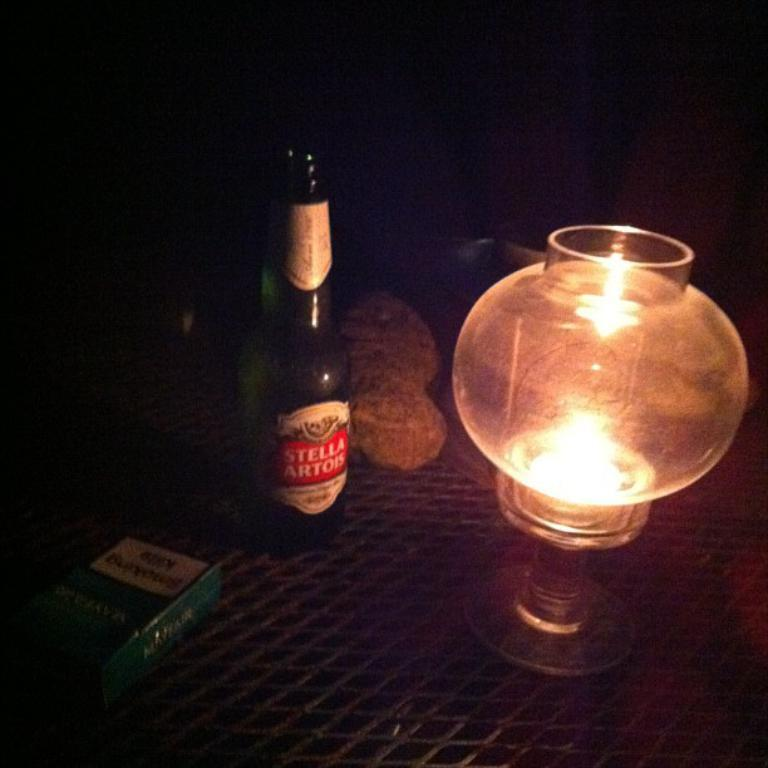<image>
Relay a brief, clear account of the picture shown. A bottle of Stella Artois sits a a table next to a lamp in a dimly lit room. 